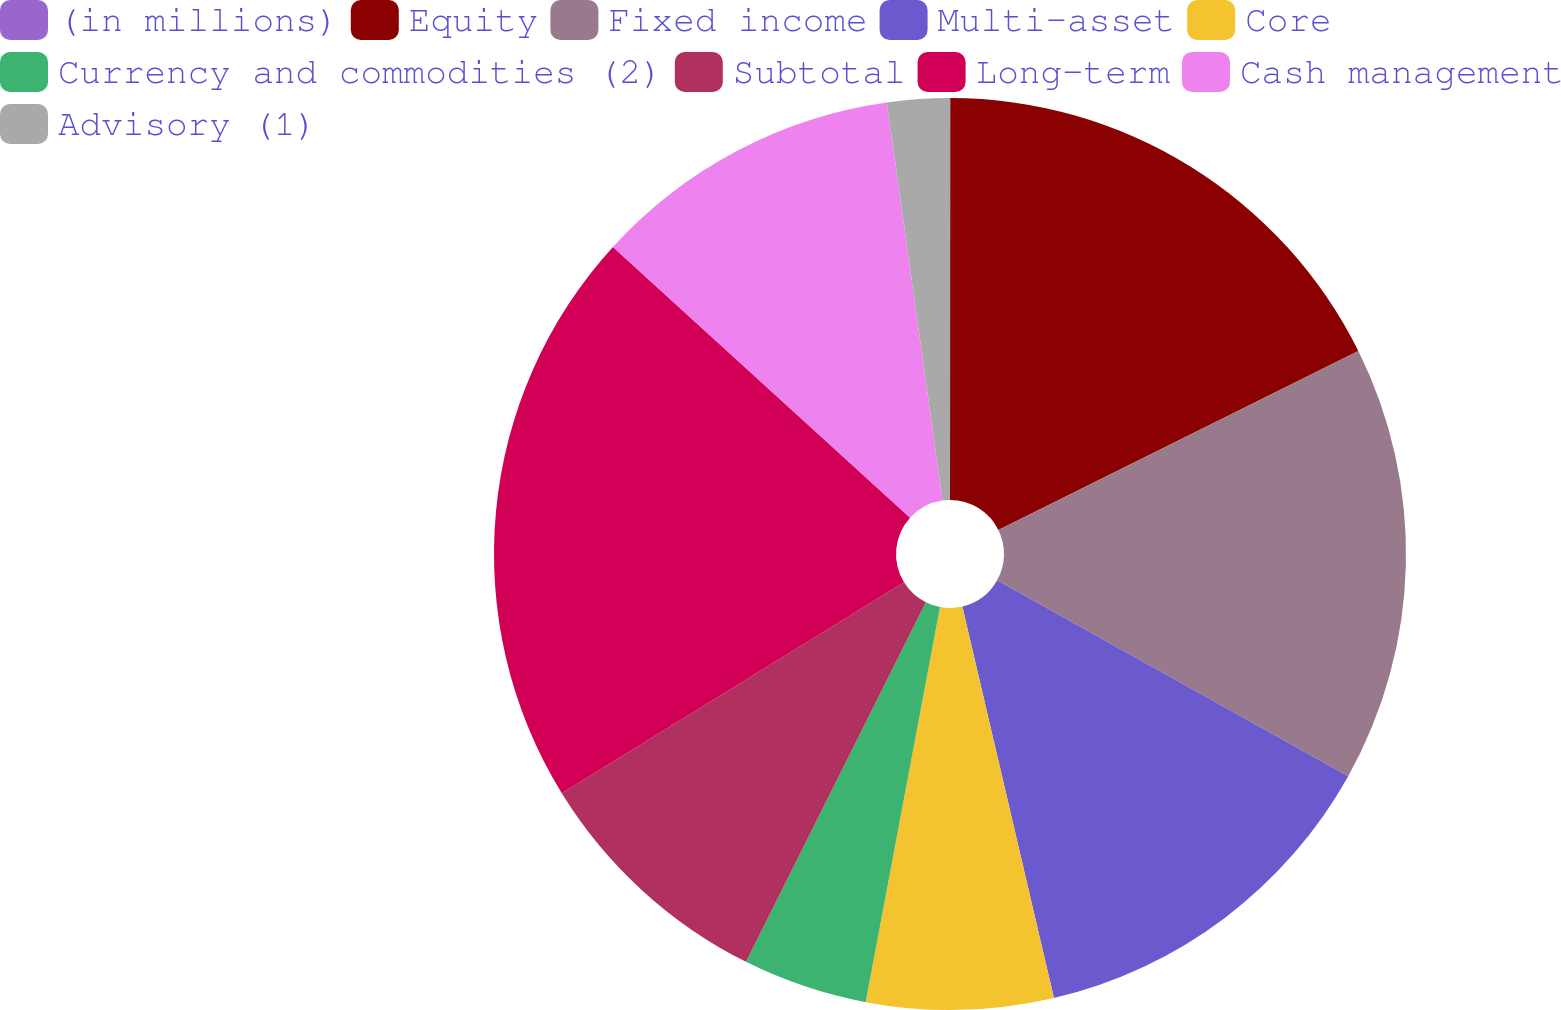Convert chart. <chart><loc_0><loc_0><loc_500><loc_500><pie_chart><fcel>(in millions)<fcel>Equity<fcel>Fixed income<fcel>Multi-asset<fcel>Core<fcel>Currency and commodities (2)<fcel>Subtotal<fcel>Long-term<fcel>Cash management<fcel>Advisory (1)<nl><fcel>0.01%<fcel>17.65%<fcel>15.44%<fcel>13.24%<fcel>6.62%<fcel>4.42%<fcel>8.83%<fcel>20.55%<fcel>11.03%<fcel>2.21%<nl></chart> 